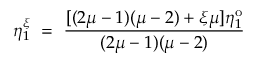<formula> <loc_0><loc_0><loc_500><loc_500>\eta _ { 1 } ^ { \xi } = \frac { [ ( 2 \mu - 1 ) ( \mu - 2 ) + \xi \mu ] \eta _ { 1 } ^ { o } } { ( 2 \mu - 1 ) ( \mu - 2 ) }</formula> 